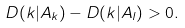Convert formula to latex. <formula><loc_0><loc_0><loc_500><loc_500>D ( k | A _ { k } ) - D ( k | A _ { l } ) > 0 .</formula> 